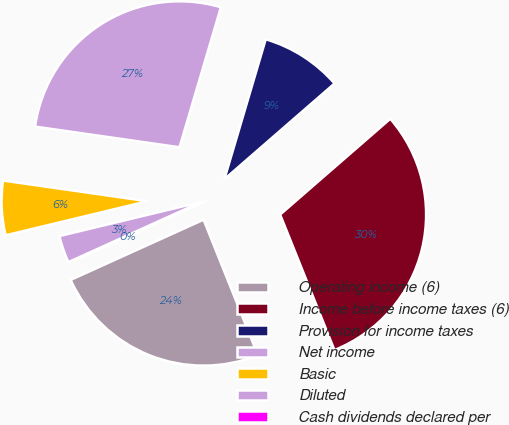<chart> <loc_0><loc_0><loc_500><loc_500><pie_chart><fcel>Operating income (6)<fcel>Income before income taxes (6)<fcel>Provision for income taxes<fcel>Net income<fcel>Basic<fcel>Diluted<fcel>Cash dividends declared per<nl><fcel>24.3%<fcel>30.32%<fcel>9.04%<fcel>27.31%<fcel>6.02%<fcel>3.01%<fcel>0.0%<nl></chart> 